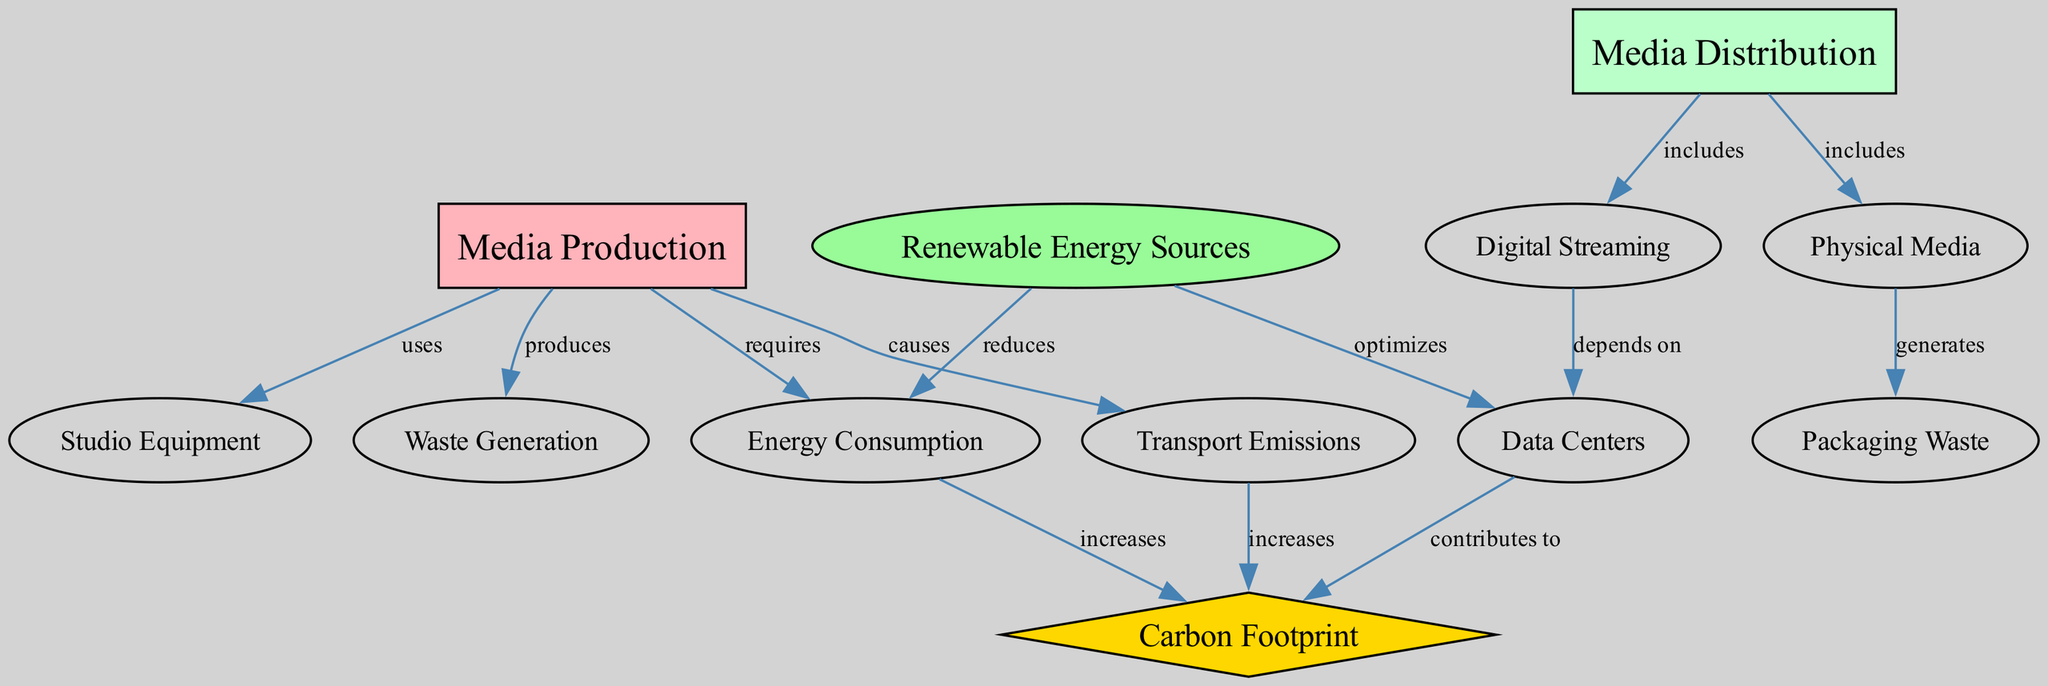What are the two main categories associated with media production? The two main categories are "Media Production" and "Media Distribution," as indicated by their prominent nodes at the top of the diagram.
Answer: Media Production, Media Distribution How many nodes are present in the diagram? The diagram comprises 12 nodes, each representing different aspects of the environmental impact of media production and distribution, as counted directly in the nodes section.
Answer: 12 What relationship does studio equipment have with media production? Studio equipment "uses" media production, which is shown by a labeled edge connecting these two nodes in the diagram.
Answer: uses Which node indicates the environmental impact of energy consumption? The node "Carbon Footprint" reflects the environmental impact linked to energy consumption, as it increases with energy consumption as shown in the edges connecting them.
Answer: Carbon Footprint How does renewable energy sources affect energy consumption? Renewable energy sources "reduces" energy consumption, as indicated by the directed edge labeled with this relationship between these two nodes in the diagram.
Answer: reduces What type of media distribution generates packaging waste? The type of media distribution that generates packaging waste is "Physical Media," which links to the "Packaging Waste" node as per the relationship defined in the diagram.
Answer: Physical Media How many edges are there in total within the diagram? The diagram contains 13 edges, each representing a distinct relationship between nodes, determined by counting each connection defined in the edges section.
Answer: 13 What kind of energy sources optimize data centers? "Renewable Energy Sources" optimize data centers, as indicated by the edge labeled with this relationship connecting the respective nodes.
Answer: Renewable Energy Sources What environmental factor increases due to transport emissions? "Carbon Footprint" increases due to transport emissions, as shown by the connection indicating that transport emissions "increases" the carbon footprint.
Answer: Carbon Footprint 